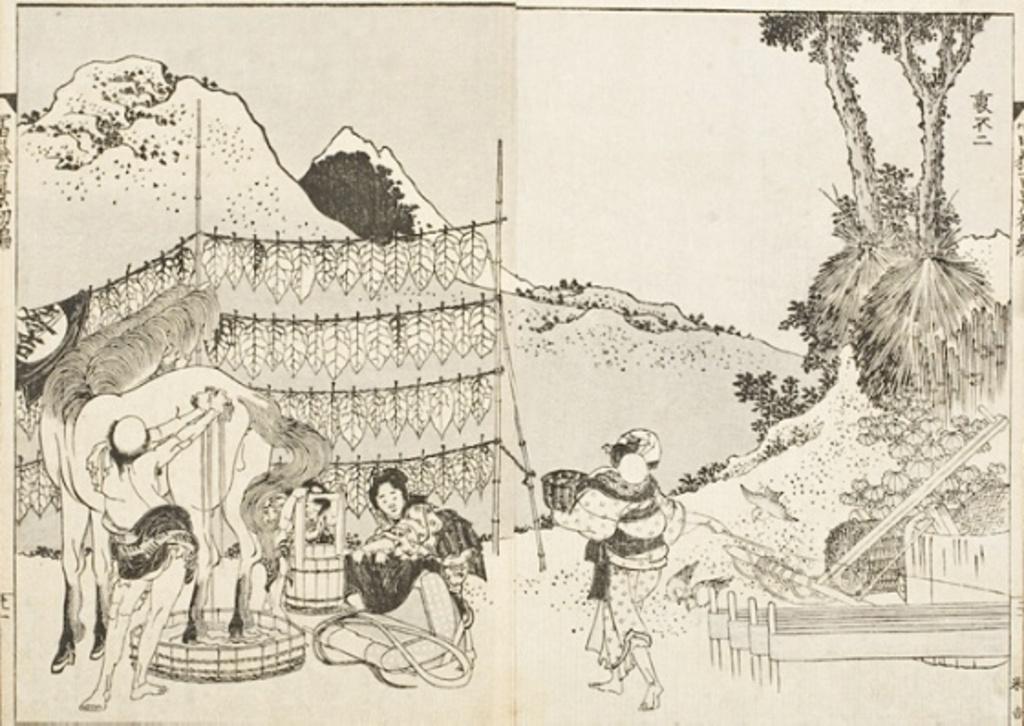In one or two sentences, can you explain what this image depicts? In the image in the center,we can see one paper. On the paper,we can see three persons,one horse,basket,cot,hills,trees,garlands etc. 